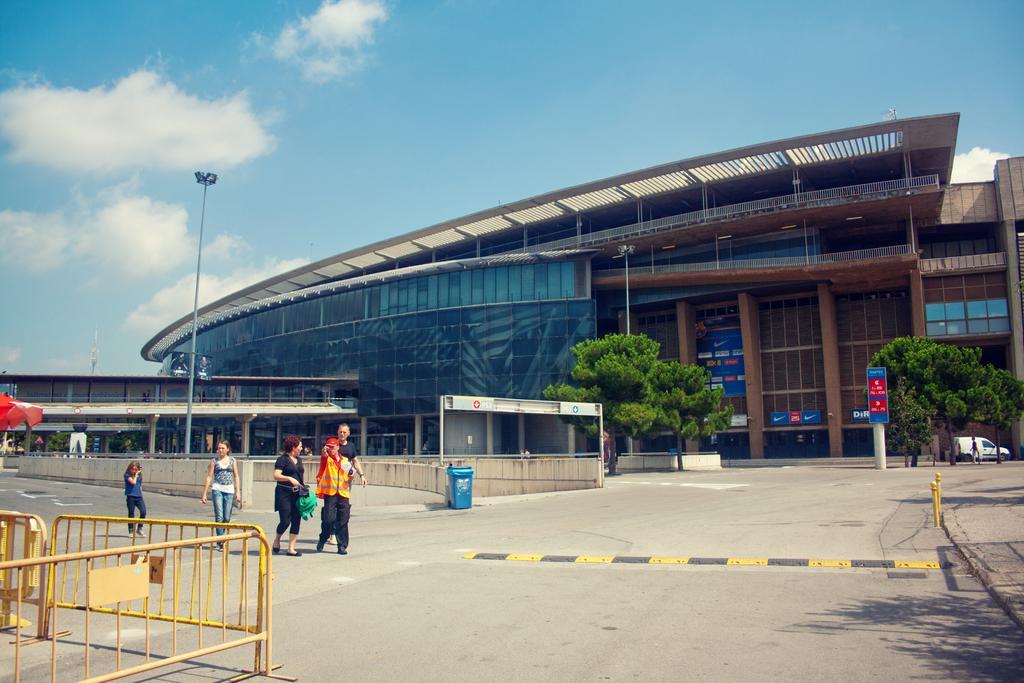Can you describe this image briefly? In the foreground of this image, there is the road and a safety railing, few persons on the road. In the background, there is a dustbin, trees, a vehicle, building, banners, pole, sky and the cloud. 